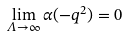Convert formula to latex. <formula><loc_0><loc_0><loc_500><loc_500>\lim _ { \Lambda \to \infty } \alpha ( - q ^ { 2 } ) = 0</formula> 